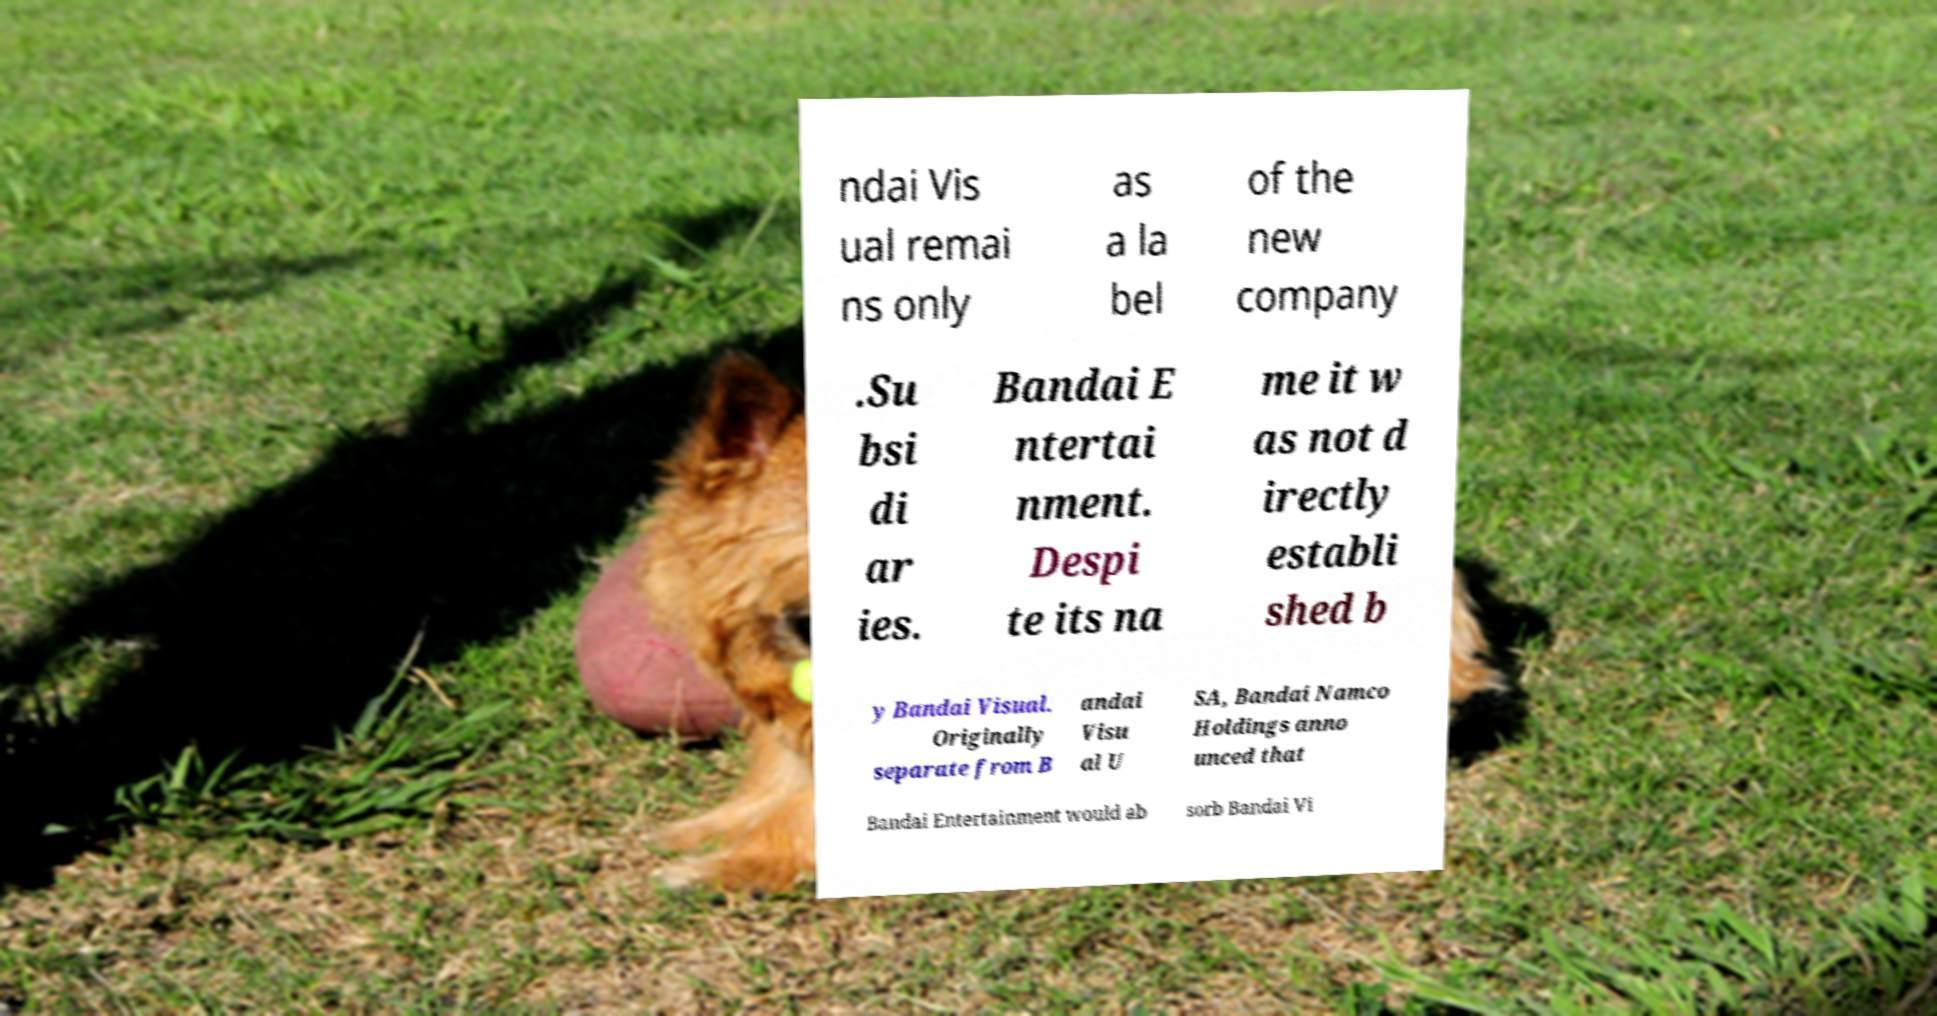Could you assist in decoding the text presented in this image and type it out clearly? ndai Vis ual remai ns only as a la bel of the new company .Su bsi di ar ies. Bandai E ntertai nment. Despi te its na me it w as not d irectly establi shed b y Bandai Visual. Originally separate from B andai Visu al U SA, Bandai Namco Holdings anno unced that Bandai Entertainment would ab sorb Bandai Vi 